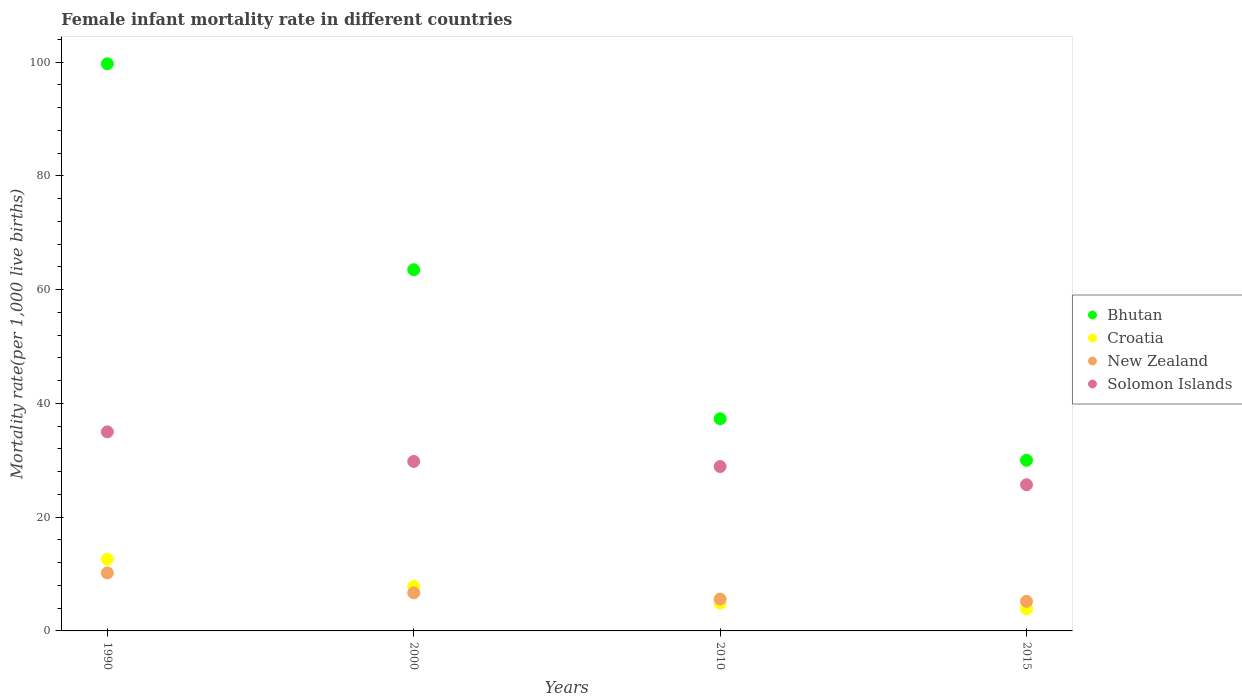Is the number of dotlines equal to the number of legend labels?
Offer a terse response. Yes. What is the female infant mortality rate in New Zealand in 1990?
Keep it short and to the point. 10.2. Across all years, what is the minimum female infant mortality rate in Solomon Islands?
Your response must be concise. 25.7. In which year was the female infant mortality rate in New Zealand minimum?
Offer a very short reply. 2015. What is the total female infant mortality rate in Bhutan in the graph?
Your response must be concise. 230.5. What is the difference between the female infant mortality rate in Croatia in 1990 and that in 2010?
Make the answer very short. 7.7. What is the difference between the female infant mortality rate in Bhutan in 2015 and the female infant mortality rate in New Zealand in 2010?
Provide a succinct answer. 24.4. What is the average female infant mortality rate in Solomon Islands per year?
Make the answer very short. 29.85. In the year 1990, what is the difference between the female infant mortality rate in Croatia and female infant mortality rate in New Zealand?
Give a very brief answer. 2.4. In how many years, is the female infant mortality rate in Solomon Islands greater than 96?
Your answer should be very brief. 0. What is the ratio of the female infant mortality rate in New Zealand in 2000 to that in 2015?
Your answer should be compact. 1.29. Is the female infant mortality rate in Bhutan in 2000 less than that in 2015?
Your answer should be very brief. No. Is the difference between the female infant mortality rate in Croatia in 1990 and 2000 greater than the difference between the female infant mortality rate in New Zealand in 1990 and 2000?
Keep it short and to the point. Yes. What is the difference between the highest and the second highest female infant mortality rate in Solomon Islands?
Provide a succinct answer. 5.2. In how many years, is the female infant mortality rate in Croatia greater than the average female infant mortality rate in Croatia taken over all years?
Make the answer very short. 2. Is it the case that in every year, the sum of the female infant mortality rate in Bhutan and female infant mortality rate in New Zealand  is greater than the female infant mortality rate in Solomon Islands?
Your answer should be very brief. Yes. How many dotlines are there?
Your answer should be compact. 4. What is the difference between two consecutive major ticks on the Y-axis?
Keep it short and to the point. 20. Are the values on the major ticks of Y-axis written in scientific E-notation?
Ensure brevity in your answer.  No. Does the graph contain any zero values?
Your answer should be very brief. No. How many legend labels are there?
Offer a very short reply. 4. How are the legend labels stacked?
Give a very brief answer. Vertical. What is the title of the graph?
Ensure brevity in your answer.  Female infant mortality rate in different countries. What is the label or title of the X-axis?
Provide a short and direct response. Years. What is the label or title of the Y-axis?
Give a very brief answer. Mortality rate(per 1,0 live births). What is the Mortality rate(per 1,000 live births) of Bhutan in 1990?
Make the answer very short. 99.7. What is the Mortality rate(per 1,000 live births) in New Zealand in 1990?
Your answer should be very brief. 10.2. What is the Mortality rate(per 1,000 live births) of Solomon Islands in 1990?
Your answer should be compact. 35. What is the Mortality rate(per 1,000 live births) of Bhutan in 2000?
Provide a succinct answer. 63.5. What is the Mortality rate(per 1,000 live births) in New Zealand in 2000?
Keep it short and to the point. 6.7. What is the Mortality rate(per 1,000 live births) in Solomon Islands in 2000?
Keep it short and to the point. 29.8. What is the Mortality rate(per 1,000 live births) of Bhutan in 2010?
Offer a very short reply. 37.3. What is the Mortality rate(per 1,000 live births) of Croatia in 2010?
Keep it short and to the point. 4.9. What is the Mortality rate(per 1,000 live births) in New Zealand in 2010?
Keep it short and to the point. 5.6. What is the Mortality rate(per 1,000 live births) of Solomon Islands in 2010?
Offer a very short reply. 28.9. What is the Mortality rate(per 1,000 live births) of Bhutan in 2015?
Offer a terse response. 30. What is the Mortality rate(per 1,000 live births) of Croatia in 2015?
Keep it short and to the point. 3.9. What is the Mortality rate(per 1,000 live births) of Solomon Islands in 2015?
Provide a short and direct response. 25.7. Across all years, what is the maximum Mortality rate(per 1,000 live births) of Bhutan?
Your answer should be very brief. 99.7. Across all years, what is the maximum Mortality rate(per 1,000 live births) of New Zealand?
Your answer should be very brief. 10.2. Across all years, what is the maximum Mortality rate(per 1,000 live births) in Solomon Islands?
Offer a terse response. 35. Across all years, what is the minimum Mortality rate(per 1,000 live births) of Bhutan?
Keep it short and to the point. 30. Across all years, what is the minimum Mortality rate(per 1,000 live births) of Croatia?
Give a very brief answer. 3.9. Across all years, what is the minimum Mortality rate(per 1,000 live births) of Solomon Islands?
Give a very brief answer. 25.7. What is the total Mortality rate(per 1,000 live births) of Bhutan in the graph?
Keep it short and to the point. 230.5. What is the total Mortality rate(per 1,000 live births) in Croatia in the graph?
Give a very brief answer. 29.2. What is the total Mortality rate(per 1,000 live births) in New Zealand in the graph?
Ensure brevity in your answer.  27.7. What is the total Mortality rate(per 1,000 live births) of Solomon Islands in the graph?
Offer a terse response. 119.4. What is the difference between the Mortality rate(per 1,000 live births) of Bhutan in 1990 and that in 2000?
Offer a terse response. 36.2. What is the difference between the Mortality rate(per 1,000 live births) of Solomon Islands in 1990 and that in 2000?
Your answer should be compact. 5.2. What is the difference between the Mortality rate(per 1,000 live births) in Bhutan in 1990 and that in 2010?
Your answer should be very brief. 62.4. What is the difference between the Mortality rate(per 1,000 live births) in Croatia in 1990 and that in 2010?
Your answer should be compact. 7.7. What is the difference between the Mortality rate(per 1,000 live births) of Bhutan in 1990 and that in 2015?
Keep it short and to the point. 69.7. What is the difference between the Mortality rate(per 1,000 live births) of Croatia in 1990 and that in 2015?
Provide a succinct answer. 8.7. What is the difference between the Mortality rate(per 1,000 live births) of Solomon Islands in 1990 and that in 2015?
Your answer should be very brief. 9.3. What is the difference between the Mortality rate(per 1,000 live births) of Bhutan in 2000 and that in 2010?
Provide a succinct answer. 26.2. What is the difference between the Mortality rate(per 1,000 live births) of Croatia in 2000 and that in 2010?
Your answer should be very brief. 2.9. What is the difference between the Mortality rate(per 1,000 live births) in Solomon Islands in 2000 and that in 2010?
Your response must be concise. 0.9. What is the difference between the Mortality rate(per 1,000 live births) of Bhutan in 2000 and that in 2015?
Ensure brevity in your answer.  33.5. What is the difference between the Mortality rate(per 1,000 live births) in New Zealand in 2000 and that in 2015?
Your response must be concise. 1.5. What is the difference between the Mortality rate(per 1,000 live births) in Bhutan in 2010 and that in 2015?
Ensure brevity in your answer.  7.3. What is the difference between the Mortality rate(per 1,000 live births) in Croatia in 2010 and that in 2015?
Give a very brief answer. 1. What is the difference between the Mortality rate(per 1,000 live births) of Solomon Islands in 2010 and that in 2015?
Provide a short and direct response. 3.2. What is the difference between the Mortality rate(per 1,000 live births) in Bhutan in 1990 and the Mortality rate(per 1,000 live births) in Croatia in 2000?
Your answer should be very brief. 91.9. What is the difference between the Mortality rate(per 1,000 live births) in Bhutan in 1990 and the Mortality rate(per 1,000 live births) in New Zealand in 2000?
Offer a terse response. 93. What is the difference between the Mortality rate(per 1,000 live births) in Bhutan in 1990 and the Mortality rate(per 1,000 live births) in Solomon Islands in 2000?
Provide a short and direct response. 69.9. What is the difference between the Mortality rate(per 1,000 live births) in Croatia in 1990 and the Mortality rate(per 1,000 live births) in Solomon Islands in 2000?
Your answer should be very brief. -17.2. What is the difference between the Mortality rate(per 1,000 live births) in New Zealand in 1990 and the Mortality rate(per 1,000 live births) in Solomon Islands in 2000?
Your answer should be very brief. -19.6. What is the difference between the Mortality rate(per 1,000 live births) of Bhutan in 1990 and the Mortality rate(per 1,000 live births) of Croatia in 2010?
Make the answer very short. 94.8. What is the difference between the Mortality rate(per 1,000 live births) of Bhutan in 1990 and the Mortality rate(per 1,000 live births) of New Zealand in 2010?
Provide a succinct answer. 94.1. What is the difference between the Mortality rate(per 1,000 live births) in Bhutan in 1990 and the Mortality rate(per 1,000 live births) in Solomon Islands in 2010?
Your response must be concise. 70.8. What is the difference between the Mortality rate(per 1,000 live births) of Croatia in 1990 and the Mortality rate(per 1,000 live births) of Solomon Islands in 2010?
Your answer should be very brief. -16.3. What is the difference between the Mortality rate(per 1,000 live births) in New Zealand in 1990 and the Mortality rate(per 1,000 live births) in Solomon Islands in 2010?
Your answer should be very brief. -18.7. What is the difference between the Mortality rate(per 1,000 live births) in Bhutan in 1990 and the Mortality rate(per 1,000 live births) in Croatia in 2015?
Offer a very short reply. 95.8. What is the difference between the Mortality rate(per 1,000 live births) of Bhutan in 1990 and the Mortality rate(per 1,000 live births) of New Zealand in 2015?
Ensure brevity in your answer.  94.5. What is the difference between the Mortality rate(per 1,000 live births) in New Zealand in 1990 and the Mortality rate(per 1,000 live births) in Solomon Islands in 2015?
Keep it short and to the point. -15.5. What is the difference between the Mortality rate(per 1,000 live births) of Bhutan in 2000 and the Mortality rate(per 1,000 live births) of Croatia in 2010?
Ensure brevity in your answer.  58.6. What is the difference between the Mortality rate(per 1,000 live births) of Bhutan in 2000 and the Mortality rate(per 1,000 live births) of New Zealand in 2010?
Provide a succinct answer. 57.9. What is the difference between the Mortality rate(per 1,000 live births) of Bhutan in 2000 and the Mortality rate(per 1,000 live births) of Solomon Islands in 2010?
Keep it short and to the point. 34.6. What is the difference between the Mortality rate(per 1,000 live births) in Croatia in 2000 and the Mortality rate(per 1,000 live births) in Solomon Islands in 2010?
Make the answer very short. -21.1. What is the difference between the Mortality rate(per 1,000 live births) in New Zealand in 2000 and the Mortality rate(per 1,000 live births) in Solomon Islands in 2010?
Make the answer very short. -22.2. What is the difference between the Mortality rate(per 1,000 live births) in Bhutan in 2000 and the Mortality rate(per 1,000 live births) in Croatia in 2015?
Provide a short and direct response. 59.6. What is the difference between the Mortality rate(per 1,000 live births) of Bhutan in 2000 and the Mortality rate(per 1,000 live births) of New Zealand in 2015?
Your answer should be compact. 58.3. What is the difference between the Mortality rate(per 1,000 live births) in Bhutan in 2000 and the Mortality rate(per 1,000 live births) in Solomon Islands in 2015?
Make the answer very short. 37.8. What is the difference between the Mortality rate(per 1,000 live births) of Croatia in 2000 and the Mortality rate(per 1,000 live births) of New Zealand in 2015?
Offer a very short reply. 2.6. What is the difference between the Mortality rate(per 1,000 live births) of Croatia in 2000 and the Mortality rate(per 1,000 live births) of Solomon Islands in 2015?
Provide a succinct answer. -17.9. What is the difference between the Mortality rate(per 1,000 live births) of Bhutan in 2010 and the Mortality rate(per 1,000 live births) of Croatia in 2015?
Provide a succinct answer. 33.4. What is the difference between the Mortality rate(per 1,000 live births) of Bhutan in 2010 and the Mortality rate(per 1,000 live births) of New Zealand in 2015?
Provide a succinct answer. 32.1. What is the difference between the Mortality rate(per 1,000 live births) in Croatia in 2010 and the Mortality rate(per 1,000 live births) in Solomon Islands in 2015?
Ensure brevity in your answer.  -20.8. What is the difference between the Mortality rate(per 1,000 live births) of New Zealand in 2010 and the Mortality rate(per 1,000 live births) of Solomon Islands in 2015?
Make the answer very short. -20.1. What is the average Mortality rate(per 1,000 live births) of Bhutan per year?
Provide a short and direct response. 57.62. What is the average Mortality rate(per 1,000 live births) in New Zealand per year?
Offer a very short reply. 6.92. What is the average Mortality rate(per 1,000 live births) in Solomon Islands per year?
Give a very brief answer. 29.85. In the year 1990, what is the difference between the Mortality rate(per 1,000 live births) in Bhutan and Mortality rate(per 1,000 live births) in Croatia?
Your answer should be compact. 87.1. In the year 1990, what is the difference between the Mortality rate(per 1,000 live births) of Bhutan and Mortality rate(per 1,000 live births) of New Zealand?
Your answer should be very brief. 89.5. In the year 1990, what is the difference between the Mortality rate(per 1,000 live births) in Bhutan and Mortality rate(per 1,000 live births) in Solomon Islands?
Give a very brief answer. 64.7. In the year 1990, what is the difference between the Mortality rate(per 1,000 live births) of Croatia and Mortality rate(per 1,000 live births) of New Zealand?
Keep it short and to the point. 2.4. In the year 1990, what is the difference between the Mortality rate(per 1,000 live births) in Croatia and Mortality rate(per 1,000 live births) in Solomon Islands?
Provide a short and direct response. -22.4. In the year 1990, what is the difference between the Mortality rate(per 1,000 live births) of New Zealand and Mortality rate(per 1,000 live births) of Solomon Islands?
Make the answer very short. -24.8. In the year 2000, what is the difference between the Mortality rate(per 1,000 live births) in Bhutan and Mortality rate(per 1,000 live births) in Croatia?
Your response must be concise. 55.7. In the year 2000, what is the difference between the Mortality rate(per 1,000 live births) in Bhutan and Mortality rate(per 1,000 live births) in New Zealand?
Ensure brevity in your answer.  56.8. In the year 2000, what is the difference between the Mortality rate(per 1,000 live births) in Bhutan and Mortality rate(per 1,000 live births) in Solomon Islands?
Offer a terse response. 33.7. In the year 2000, what is the difference between the Mortality rate(per 1,000 live births) in Croatia and Mortality rate(per 1,000 live births) in New Zealand?
Your answer should be compact. 1.1. In the year 2000, what is the difference between the Mortality rate(per 1,000 live births) in Croatia and Mortality rate(per 1,000 live births) in Solomon Islands?
Give a very brief answer. -22. In the year 2000, what is the difference between the Mortality rate(per 1,000 live births) in New Zealand and Mortality rate(per 1,000 live births) in Solomon Islands?
Provide a short and direct response. -23.1. In the year 2010, what is the difference between the Mortality rate(per 1,000 live births) in Bhutan and Mortality rate(per 1,000 live births) in Croatia?
Give a very brief answer. 32.4. In the year 2010, what is the difference between the Mortality rate(per 1,000 live births) in Bhutan and Mortality rate(per 1,000 live births) in New Zealand?
Offer a very short reply. 31.7. In the year 2010, what is the difference between the Mortality rate(per 1,000 live births) of Croatia and Mortality rate(per 1,000 live births) of New Zealand?
Make the answer very short. -0.7. In the year 2010, what is the difference between the Mortality rate(per 1,000 live births) of Croatia and Mortality rate(per 1,000 live births) of Solomon Islands?
Provide a succinct answer. -24. In the year 2010, what is the difference between the Mortality rate(per 1,000 live births) in New Zealand and Mortality rate(per 1,000 live births) in Solomon Islands?
Make the answer very short. -23.3. In the year 2015, what is the difference between the Mortality rate(per 1,000 live births) in Bhutan and Mortality rate(per 1,000 live births) in Croatia?
Offer a very short reply. 26.1. In the year 2015, what is the difference between the Mortality rate(per 1,000 live births) in Bhutan and Mortality rate(per 1,000 live births) in New Zealand?
Ensure brevity in your answer.  24.8. In the year 2015, what is the difference between the Mortality rate(per 1,000 live births) of Bhutan and Mortality rate(per 1,000 live births) of Solomon Islands?
Your response must be concise. 4.3. In the year 2015, what is the difference between the Mortality rate(per 1,000 live births) of Croatia and Mortality rate(per 1,000 live births) of New Zealand?
Provide a succinct answer. -1.3. In the year 2015, what is the difference between the Mortality rate(per 1,000 live births) in Croatia and Mortality rate(per 1,000 live births) in Solomon Islands?
Your answer should be compact. -21.8. In the year 2015, what is the difference between the Mortality rate(per 1,000 live births) in New Zealand and Mortality rate(per 1,000 live births) in Solomon Islands?
Keep it short and to the point. -20.5. What is the ratio of the Mortality rate(per 1,000 live births) in Bhutan in 1990 to that in 2000?
Provide a succinct answer. 1.57. What is the ratio of the Mortality rate(per 1,000 live births) of Croatia in 1990 to that in 2000?
Your response must be concise. 1.62. What is the ratio of the Mortality rate(per 1,000 live births) in New Zealand in 1990 to that in 2000?
Give a very brief answer. 1.52. What is the ratio of the Mortality rate(per 1,000 live births) of Solomon Islands in 1990 to that in 2000?
Offer a terse response. 1.17. What is the ratio of the Mortality rate(per 1,000 live births) in Bhutan in 1990 to that in 2010?
Your answer should be compact. 2.67. What is the ratio of the Mortality rate(per 1,000 live births) of Croatia in 1990 to that in 2010?
Your answer should be compact. 2.57. What is the ratio of the Mortality rate(per 1,000 live births) in New Zealand in 1990 to that in 2010?
Your answer should be very brief. 1.82. What is the ratio of the Mortality rate(per 1,000 live births) in Solomon Islands in 1990 to that in 2010?
Make the answer very short. 1.21. What is the ratio of the Mortality rate(per 1,000 live births) in Bhutan in 1990 to that in 2015?
Offer a terse response. 3.32. What is the ratio of the Mortality rate(per 1,000 live births) in Croatia in 1990 to that in 2015?
Your response must be concise. 3.23. What is the ratio of the Mortality rate(per 1,000 live births) in New Zealand in 1990 to that in 2015?
Keep it short and to the point. 1.96. What is the ratio of the Mortality rate(per 1,000 live births) in Solomon Islands in 1990 to that in 2015?
Your answer should be compact. 1.36. What is the ratio of the Mortality rate(per 1,000 live births) of Bhutan in 2000 to that in 2010?
Give a very brief answer. 1.7. What is the ratio of the Mortality rate(per 1,000 live births) in Croatia in 2000 to that in 2010?
Ensure brevity in your answer.  1.59. What is the ratio of the Mortality rate(per 1,000 live births) of New Zealand in 2000 to that in 2010?
Keep it short and to the point. 1.2. What is the ratio of the Mortality rate(per 1,000 live births) in Solomon Islands in 2000 to that in 2010?
Give a very brief answer. 1.03. What is the ratio of the Mortality rate(per 1,000 live births) in Bhutan in 2000 to that in 2015?
Ensure brevity in your answer.  2.12. What is the ratio of the Mortality rate(per 1,000 live births) in Croatia in 2000 to that in 2015?
Provide a short and direct response. 2. What is the ratio of the Mortality rate(per 1,000 live births) in New Zealand in 2000 to that in 2015?
Keep it short and to the point. 1.29. What is the ratio of the Mortality rate(per 1,000 live births) of Solomon Islands in 2000 to that in 2015?
Provide a short and direct response. 1.16. What is the ratio of the Mortality rate(per 1,000 live births) in Bhutan in 2010 to that in 2015?
Your response must be concise. 1.24. What is the ratio of the Mortality rate(per 1,000 live births) in Croatia in 2010 to that in 2015?
Offer a very short reply. 1.26. What is the ratio of the Mortality rate(per 1,000 live births) of New Zealand in 2010 to that in 2015?
Your answer should be compact. 1.08. What is the ratio of the Mortality rate(per 1,000 live births) in Solomon Islands in 2010 to that in 2015?
Make the answer very short. 1.12. What is the difference between the highest and the second highest Mortality rate(per 1,000 live births) in Bhutan?
Provide a short and direct response. 36.2. What is the difference between the highest and the second highest Mortality rate(per 1,000 live births) in Croatia?
Make the answer very short. 4.8. What is the difference between the highest and the lowest Mortality rate(per 1,000 live births) of Bhutan?
Your answer should be very brief. 69.7. What is the difference between the highest and the lowest Mortality rate(per 1,000 live births) of Solomon Islands?
Give a very brief answer. 9.3. 